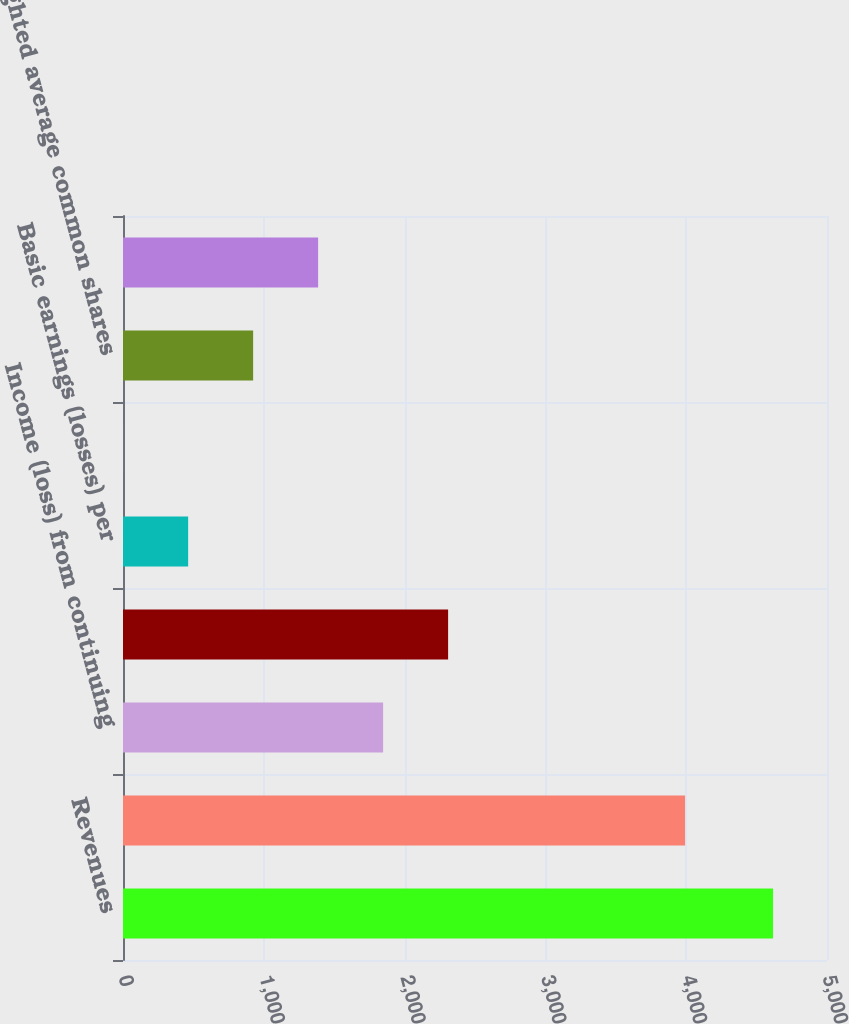Convert chart to OTSL. <chart><loc_0><loc_0><loc_500><loc_500><bar_chart><fcel>Revenues<fcel>Benefits losses and expenses<fcel>Income (loss) from continuing<fcel>Net income (loss)<fcel>Basic earnings (losses) per<fcel>Diluted earnings (losses) per<fcel>Weighted average common shares<fcel>Weighted average shares<nl><fcel>4617<fcel>3992<fcel>1847.44<fcel>2309.03<fcel>462.67<fcel>1.08<fcel>924.26<fcel>1385.85<nl></chart> 